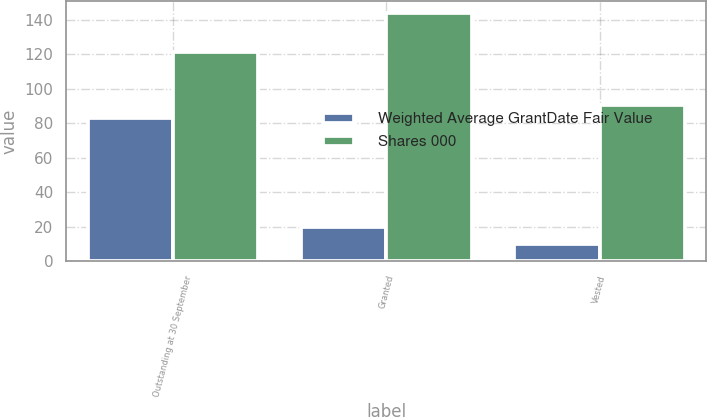Convert chart to OTSL. <chart><loc_0><loc_0><loc_500><loc_500><stacked_bar_chart><ecel><fcel>Outstanding at 30 September<fcel>Granted<fcel>Vested<nl><fcel>Weighted Average GrantDate Fair Value<fcel>83<fcel>20<fcel>10<nl><fcel>Shares 000<fcel>121.17<fcel>144.09<fcel>90.67<nl></chart> 